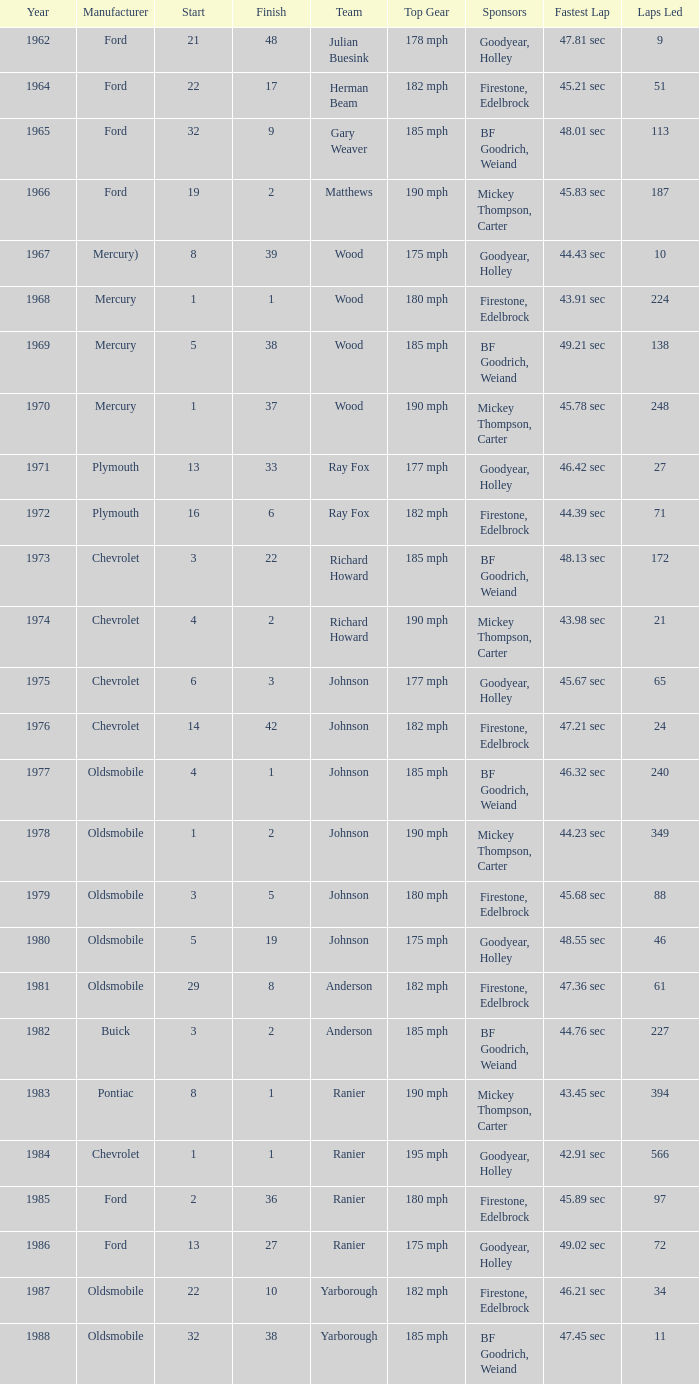What is the smallest finish time for a race after 1972 with a car manufactured by pontiac? 1.0. 